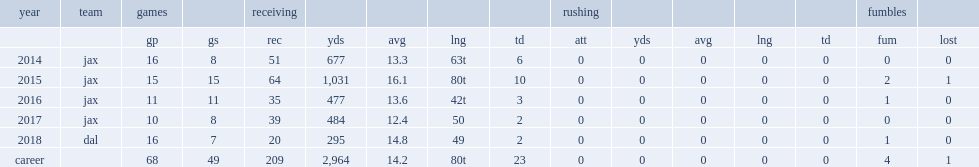How many receptions did hurns get in 2014? 51.0. 